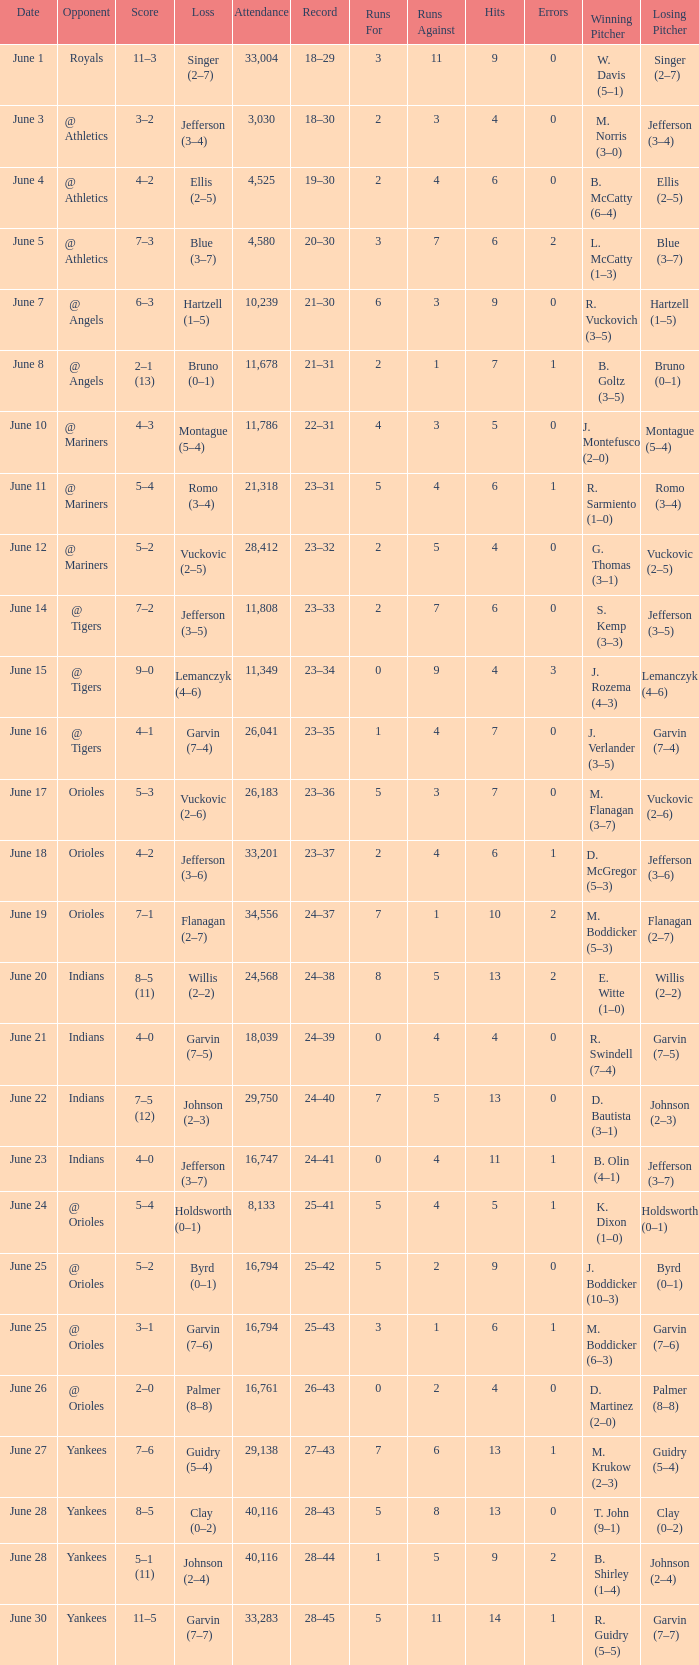Who was the opponent at the game when the record was 28–45? Yankees. 